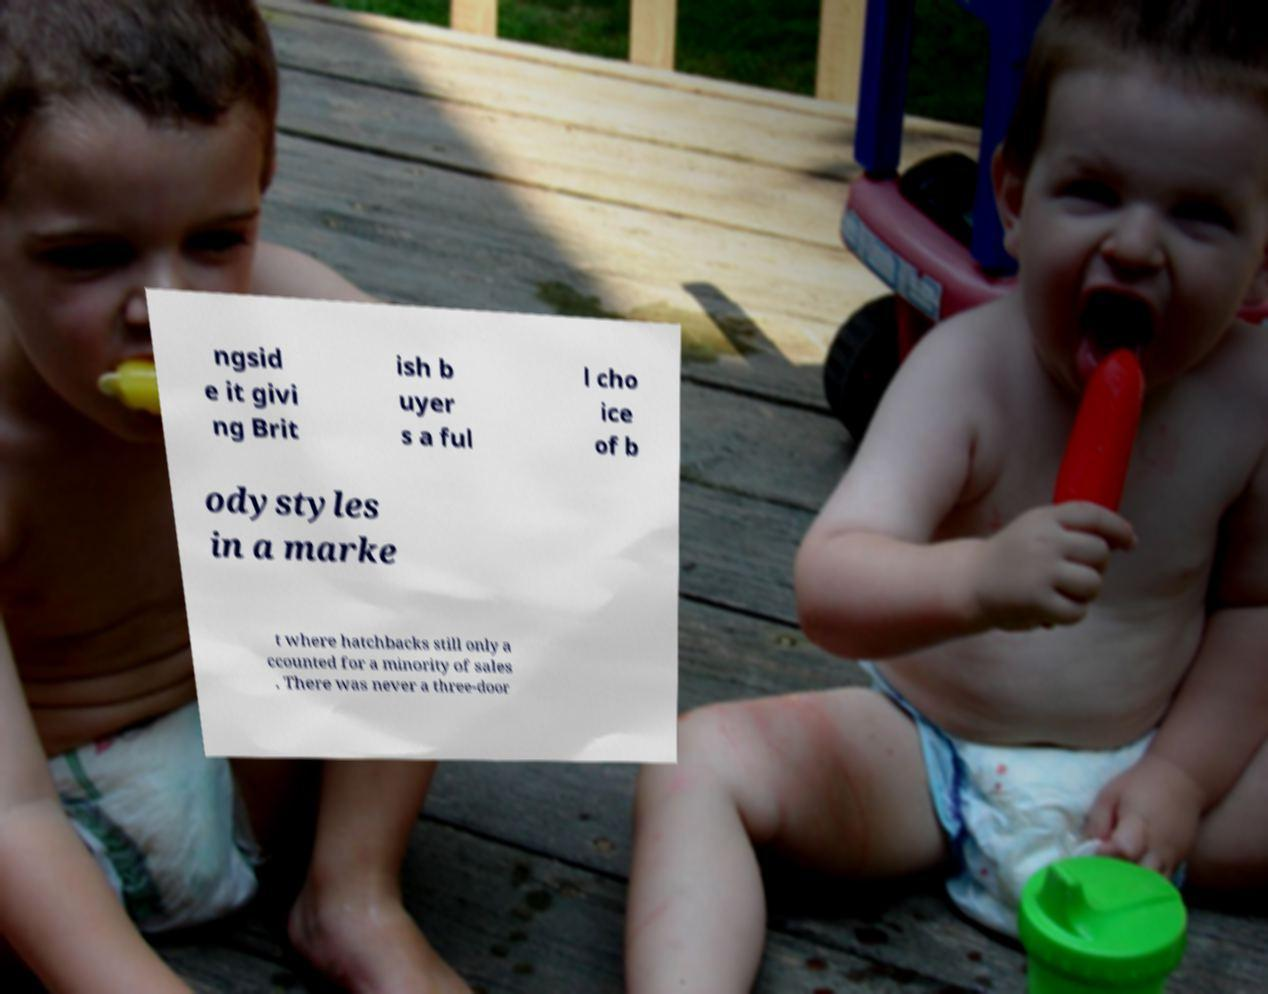Please read and relay the text visible in this image. What does it say? ngsid e it givi ng Brit ish b uyer s a ful l cho ice of b odystyles in a marke t where hatchbacks still only a ccounted for a minority of sales . There was never a three-door 